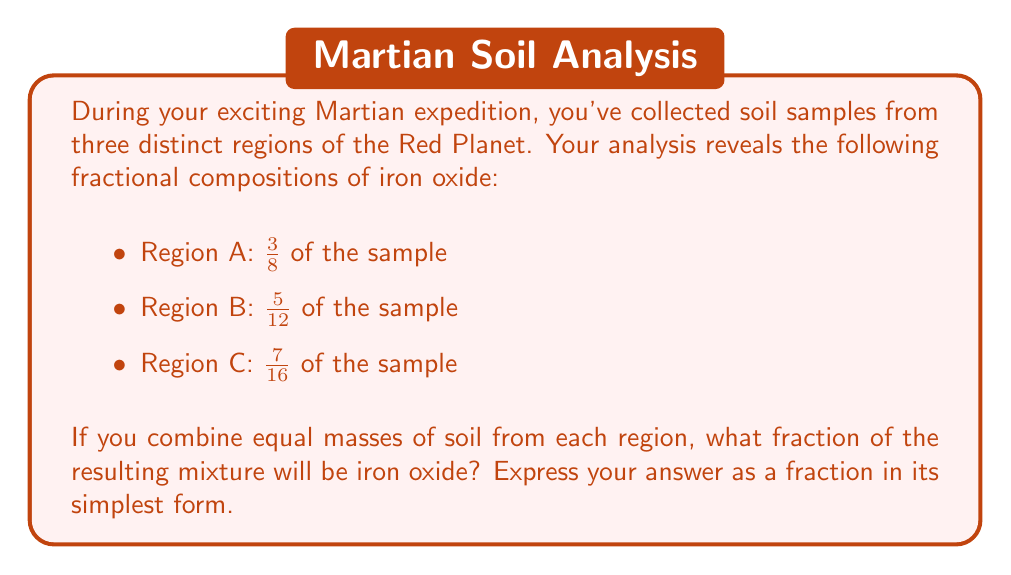Solve this math problem. Let's approach this step-by-step:

1) First, we need to find the average of the three fractions. Since we're combining equal masses from each region, we can simply add the fractions and divide by 3.

2) To add fractions with different denominators, we need to find a common denominator. The least common multiple of 8, 12, and 16 is 48. Let's convert each fraction to an equivalent fraction with denominator 48:

   $\frac{3}{8} = \frac{3 \times 6}{8 \times 6} = \frac{18}{48}$
   $\frac{5}{12} = \frac{5 \times 4}{12 \times 4} = \frac{20}{48}$
   $\frac{7}{16} = \frac{7 \times 3}{16 \times 3} = \frac{21}{48}$

3) Now we can add these fractions:

   $\frac{18}{48} + \frac{20}{48} + \frac{21}{48} = \frac{59}{48}$

4) To find the average, we divide by 3:

   $\frac{59}{48} \div 3 = \frac{59}{144}$

5) This fraction is already in its simplest form, as 59 and 144 have no common factors other than 1.

Therefore, the fraction of iron oxide in the combined sample is $\frac{59}{144}$.
Answer: $\frac{59}{144}$ 